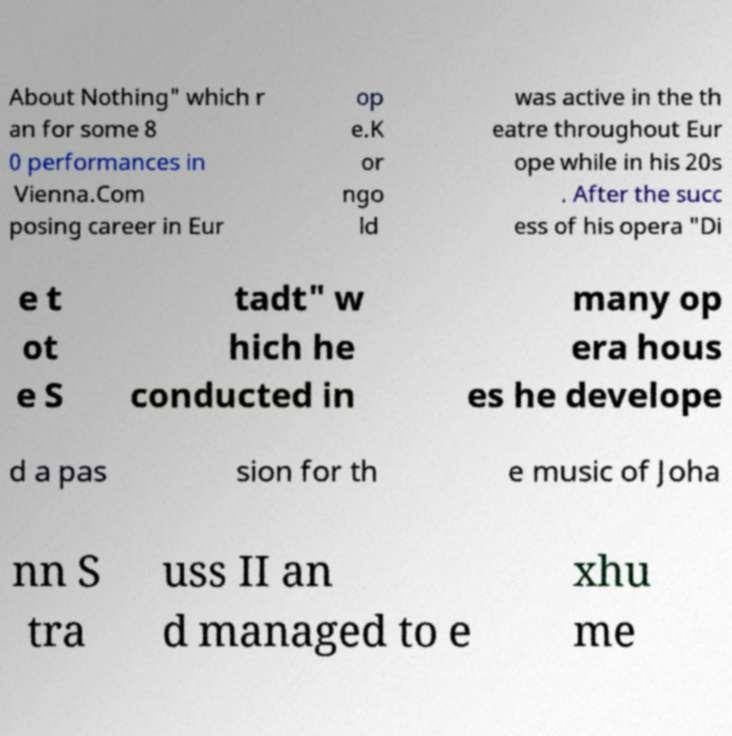For documentation purposes, I need the text within this image transcribed. Could you provide that? About Nothing" which r an for some 8 0 performances in Vienna.Com posing career in Eur op e.K or ngo ld was active in the th eatre throughout Eur ope while in his 20s . After the succ ess of his opera "Di e t ot e S tadt" w hich he conducted in many op era hous es he develope d a pas sion for th e music of Joha nn S tra uss II an d managed to e xhu me 